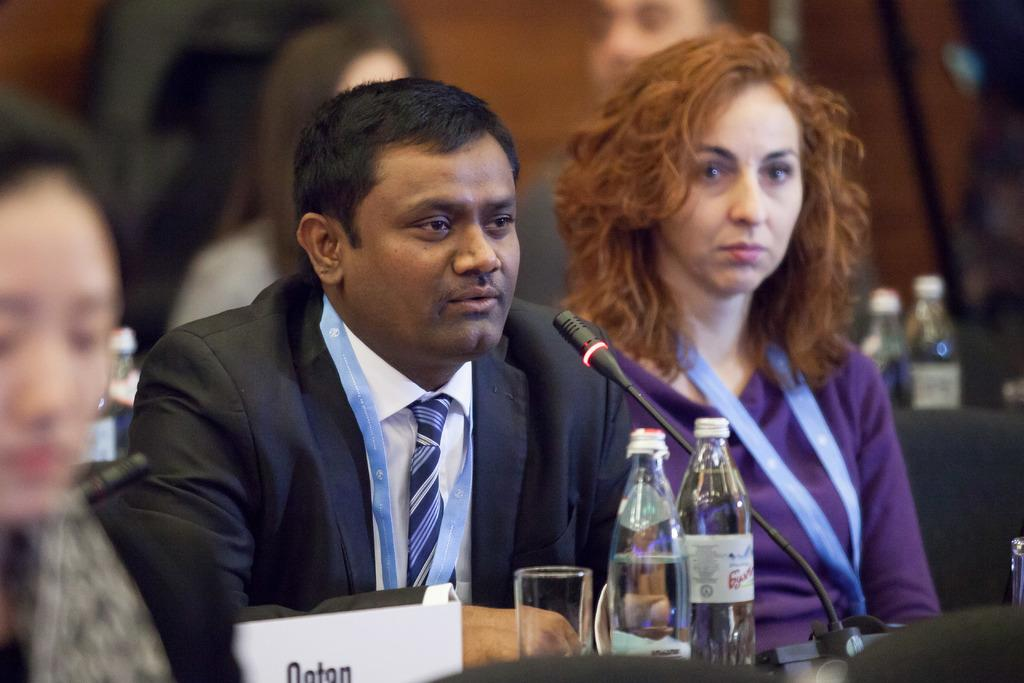What are the people in the image doing? The people in the image are sitting. What object in the image might indicate a specific location or event? There is a name board in the image, which might indicate a specific location or event. What type of container is visible in the image? There is a glass in the image. How many bottles can be seen in the image? There are two bottles in the image. What object in the image is used for amplifying sound? There is a microphone in the image, which is used for amplifying sound. How would you describe the background of the image? The background of the image is blurry. What type of food is being served in the oatmeal bowl in the image? There is no oatmeal bowl present in the image. Can you describe the sea creatures visible in the image? There are no sea creatures visible in the image. 